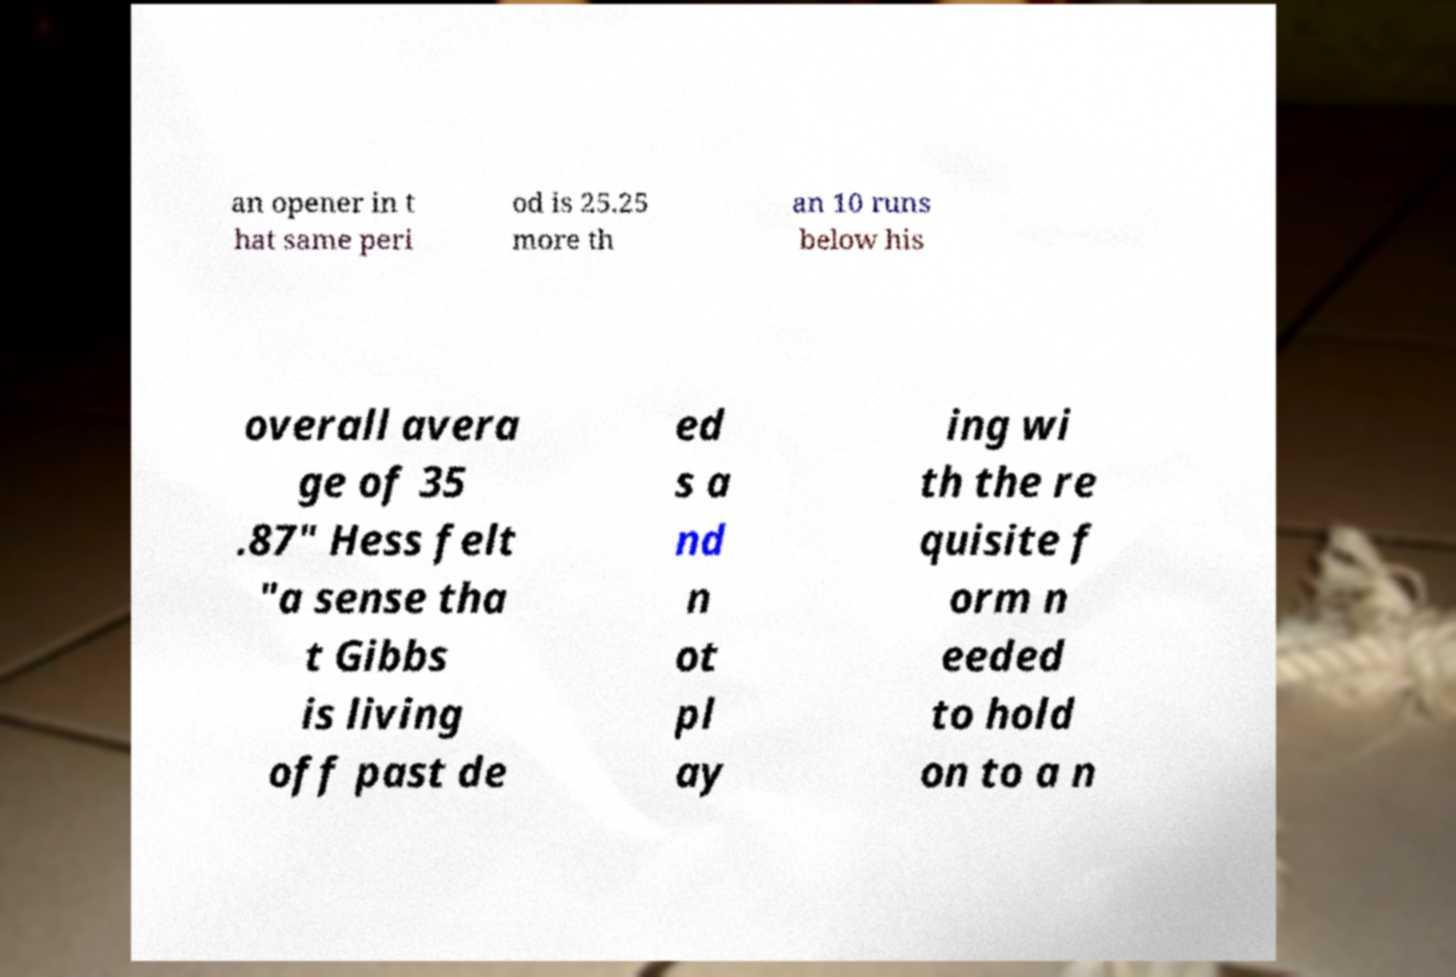What messages or text are displayed in this image? I need them in a readable, typed format. an opener in t hat same peri od is 25.25 more th an 10 runs below his overall avera ge of 35 .87" Hess felt "a sense tha t Gibbs is living off past de ed s a nd n ot pl ay ing wi th the re quisite f orm n eeded to hold on to a n 